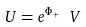Convert formula to latex. <formula><loc_0><loc_0><loc_500><loc_500>U = e ^ { \Phi _ { + } } \ V</formula> 